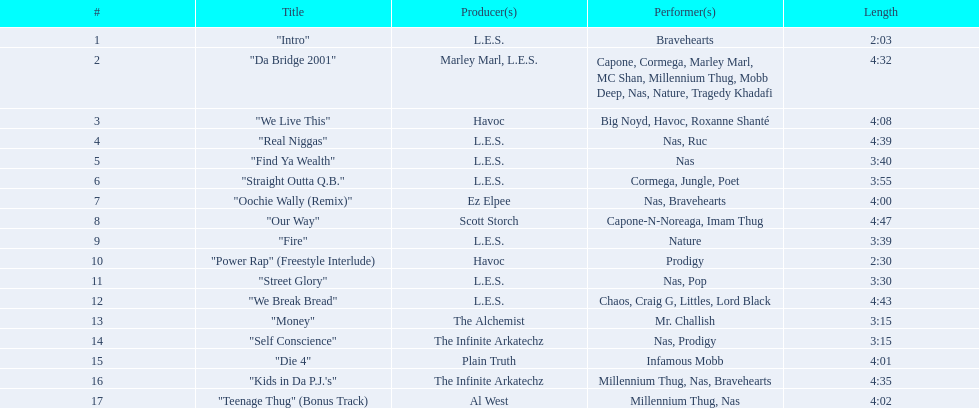How long is each song? 2:03, 4:32, 4:08, 4:39, 3:40, 3:55, 4:00, 4:47, 3:39, 2:30, 3:30, 4:43, 3:15, 3:15, 4:01, 4:35, 4:02. Of those, which length is the shortest? 2:03. 